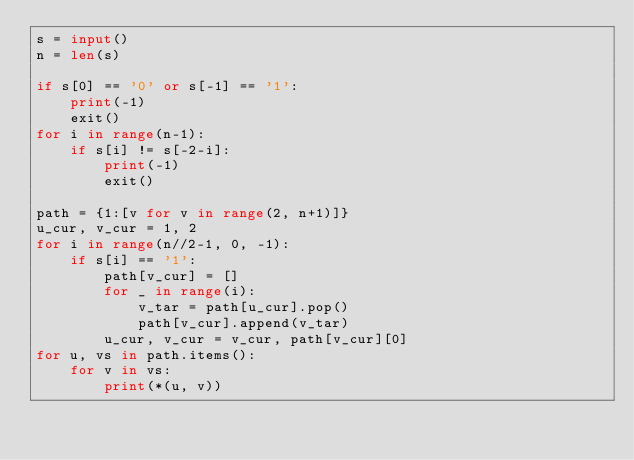Convert code to text. <code><loc_0><loc_0><loc_500><loc_500><_Python_>s = input()
n = len(s)

if s[0] == '0' or s[-1] == '1':
    print(-1)
    exit()
for i in range(n-1):
    if s[i] != s[-2-i]:
        print(-1)
        exit()

path = {1:[v for v in range(2, n+1)]}
u_cur, v_cur = 1, 2
for i in range(n//2-1, 0, -1):
    if s[i] == '1':
        path[v_cur] = []
        for _ in range(i):
            v_tar = path[u_cur].pop()
            path[v_cur].append(v_tar)
        u_cur, v_cur = v_cur, path[v_cur][0]
for u, vs in path.items():
    for v in vs:
        print(*(u, v))
</code> 